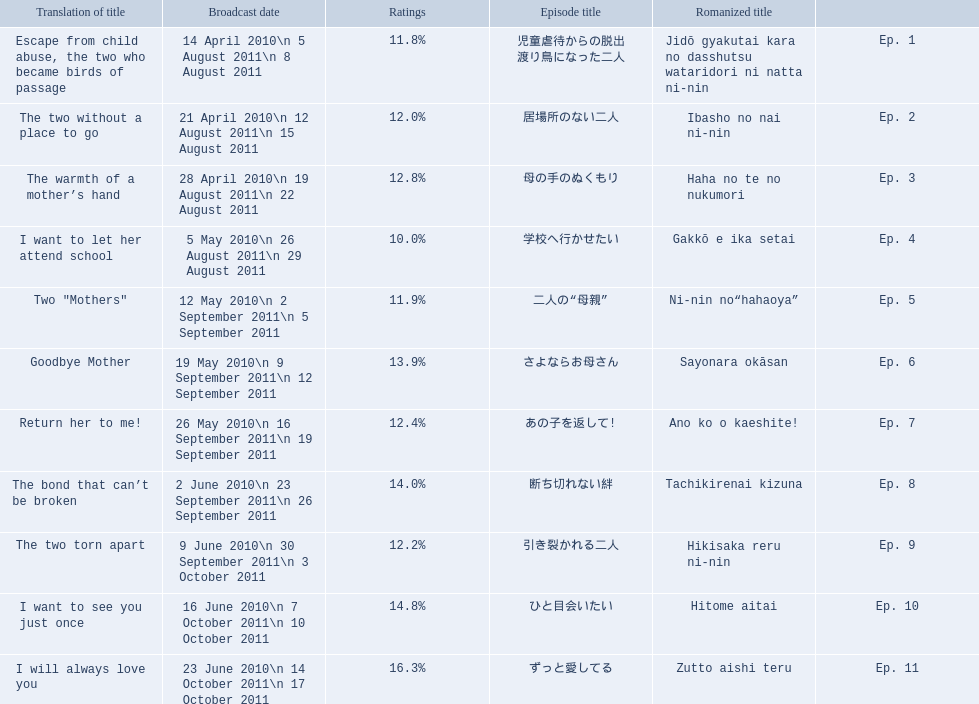What is the name of epsiode 8? 断ち切れない絆. What were this episodes ratings? 14.0%. 